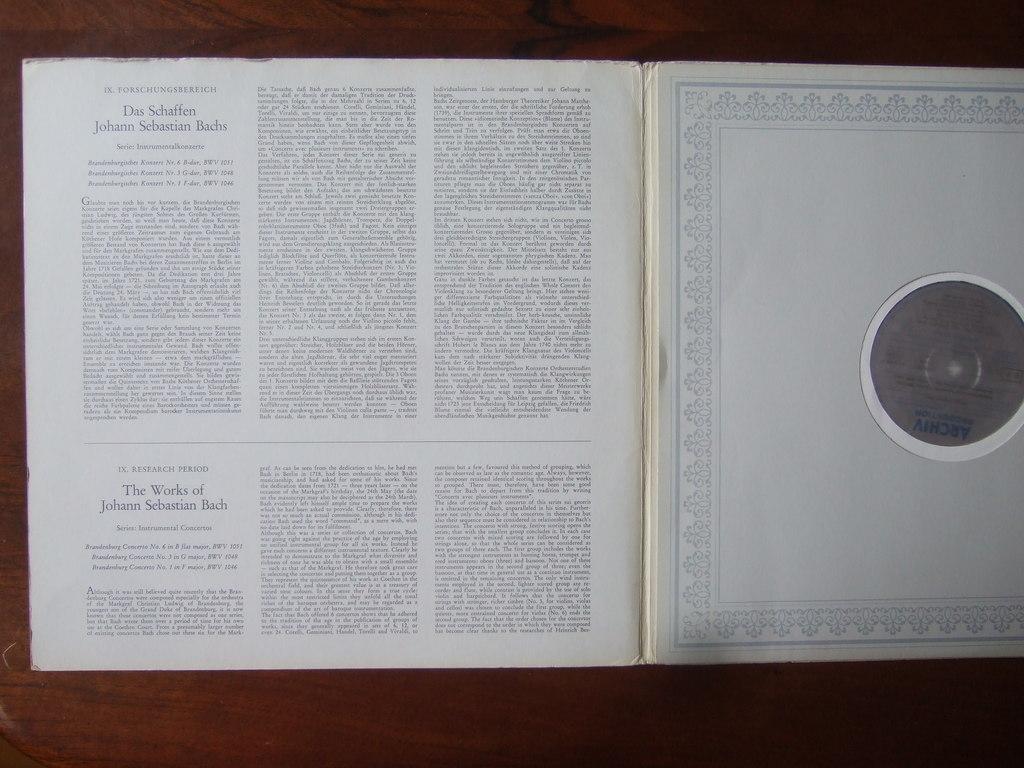This contains the work of which artist?
Keep it short and to the point. Johann sebastian bach. Can you be able to read this article?
Provide a short and direct response. No. 